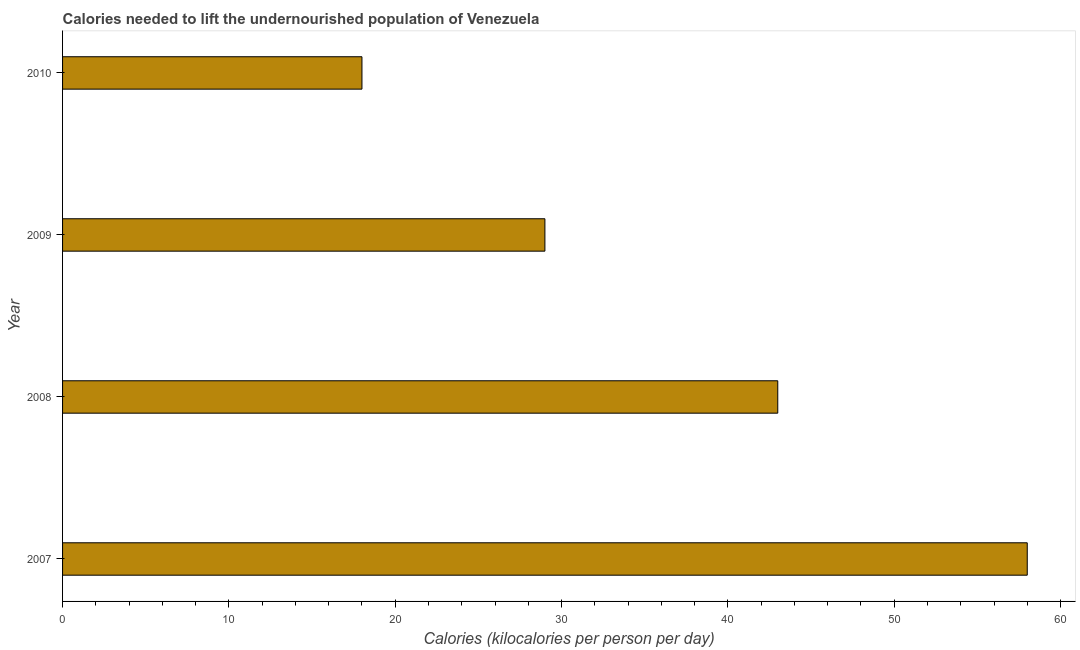Does the graph contain any zero values?
Your response must be concise. No. Does the graph contain grids?
Provide a short and direct response. No. What is the title of the graph?
Ensure brevity in your answer.  Calories needed to lift the undernourished population of Venezuela. What is the label or title of the X-axis?
Make the answer very short. Calories (kilocalories per person per day). Across all years, what is the maximum depth of food deficit?
Give a very brief answer. 58. In which year was the depth of food deficit maximum?
Give a very brief answer. 2007. In which year was the depth of food deficit minimum?
Your response must be concise. 2010. What is the sum of the depth of food deficit?
Provide a short and direct response. 148. What is the median depth of food deficit?
Ensure brevity in your answer.  36. What is the ratio of the depth of food deficit in 2007 to that in 2009?
Make the answer very short. 2. Is the sum of the depth of food deficit in 2009 and 2010 greater than the maximum depth of food deficit across all years?
Make the answer very short. No. In how many years, is the depth of food deficit greater than the average depth of food deficit taken over all years?
Give a very brief answer. 2. How many bars are there?
Give a very brief answer. 4. Are all the bars in the graph horizontal?
Provide a succinct answer. Yes. What is the Calories (kilocalories per person per day) in 2008?
Keep it short and to the point. 43. What is the Calories (kilocalories per person per day) in 2009?
Keep it short and to the point. 29. What is the difference between the Calories (kilocalories per person per day) in 2007 and 2008?
Offer a terse response. 15. What is the difference between the Calories (kilocalories per person per day) in 2007 and 2010?
Provide a short and direct response. 40. What is the difference between the Calories (kilocalories per person per day) in 2009 and 2010?
Offer a very short reply. 11. What is the ratio of the Calories (kilocalories per person per day) in 2007 to that in 2008?
Make the answer very short. 1.35. What is the ratio of the Calories (kilocalories per person per day) in 2007 to that in 2010?
Offer a terse response. 3.22. What is the ratio of the Calories (kilocalories per person per day) in 2008 to that in 2009?
Ensure brevity in your answer.  1.48. What is the ratio of the Calories (kilocalories per person per day) in 2008 to that in 2010?
Keep it short and to the point. 2.39. What is the ratio of the Calories (kilocalories per person per day) in 2009 to that in 2010?
Your response must be concise. 1.61. 